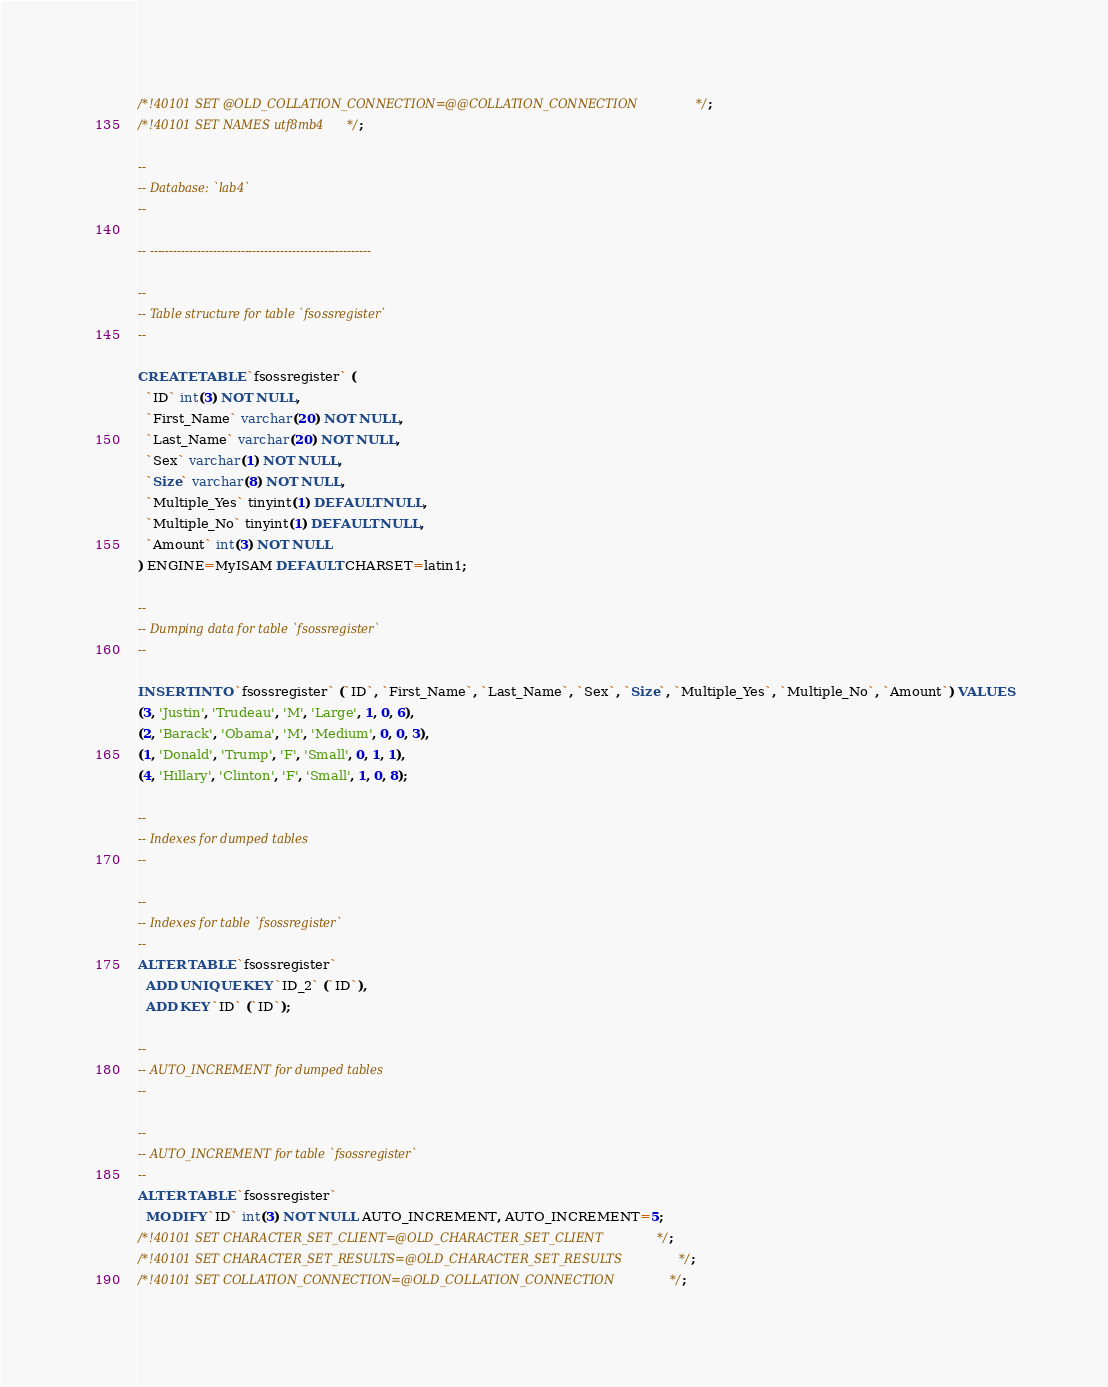<code> <loc_0><loc_0><loc_500><loc_500><_SQL_>/*!40101 SET @OLD_COLLATION_CONNECTION=@@COLLATION_CONNECTION */;
/*!40101 SET NAMES utf8mb4 */;

--
-- Database: `lab4`
--

-- --------------------------------------------------------

--
-- Table structure for table `fsossregister`
--

CREATE TABLE `fsossregister` (
  `ID` int(3) NOT NULL,
  `First_Name` varchar(20) NOT NULL,
  `Last_Name` varchar(20) NOT NULL,
  `Sex` varchar(1) NOT NULL,
  `Size` varchar(8) NOT NULL,
  `Multiple_Yes` tinyint(1) DEFAULT NULL,
  `Multiple_No` tinyint(1) DEFAULT NULL,
  `Amount` int(3) NOT NULL
) ENGINE=MyISAM DEFAULT CHARSET=latin1;

--
-- Dumping data for table `fsossregister`
--

INSERT INTO `fsossregister` (`ID`, `First_Name`, `Last_Name`, `Sex`, `Size`, `Multiple_Yes`, `Multiple_No`, `Amount`) VALUES
(3, 'Justin', 'Trudeau', 'M', 'Large', 1, 0, 6),
(2, 'Barack', 'Obama', 'M', 'Medium', 0, 0, 3),
(1, 'Donald', 'Trump', 'F', 'Small', 0, 1, 1),
(4, 'Hillary', 'Clinton', 'F', 'Small', 1, 0, 8);

--
-- Indexes for dumped tables
--

--
-- Indexes for table `fsossregister`
--
ALTER TABLE `fsossregister`
  ADD UNIQUE KEY `ID_2` (`ID`),
  ADD KEY `ID` (`ID`);

--
-- AUTO_INCREMENT for dumped tables
--

--
-- AUTO_INCREMENT for table `fsossregister`
--
ALTER TABLE `fsossregister`
  MODIFY `ID` int(3) NOT NULL AUTO_INCREMENT, AUTO_INCREMENT=5;
/*!40101 SET CHARACTER_SET_CLIENT=@OLD_CHARACTER_SET_CLIENT */;
/*!40101 SET CHARACTER_SET_RESULTS=@OLD_CHARACTER_SET_RESULTS */;
/*!40101 SET COLLATION_CONNECTION=@OLD_COLLATION_CONNECTION */;
</code> 